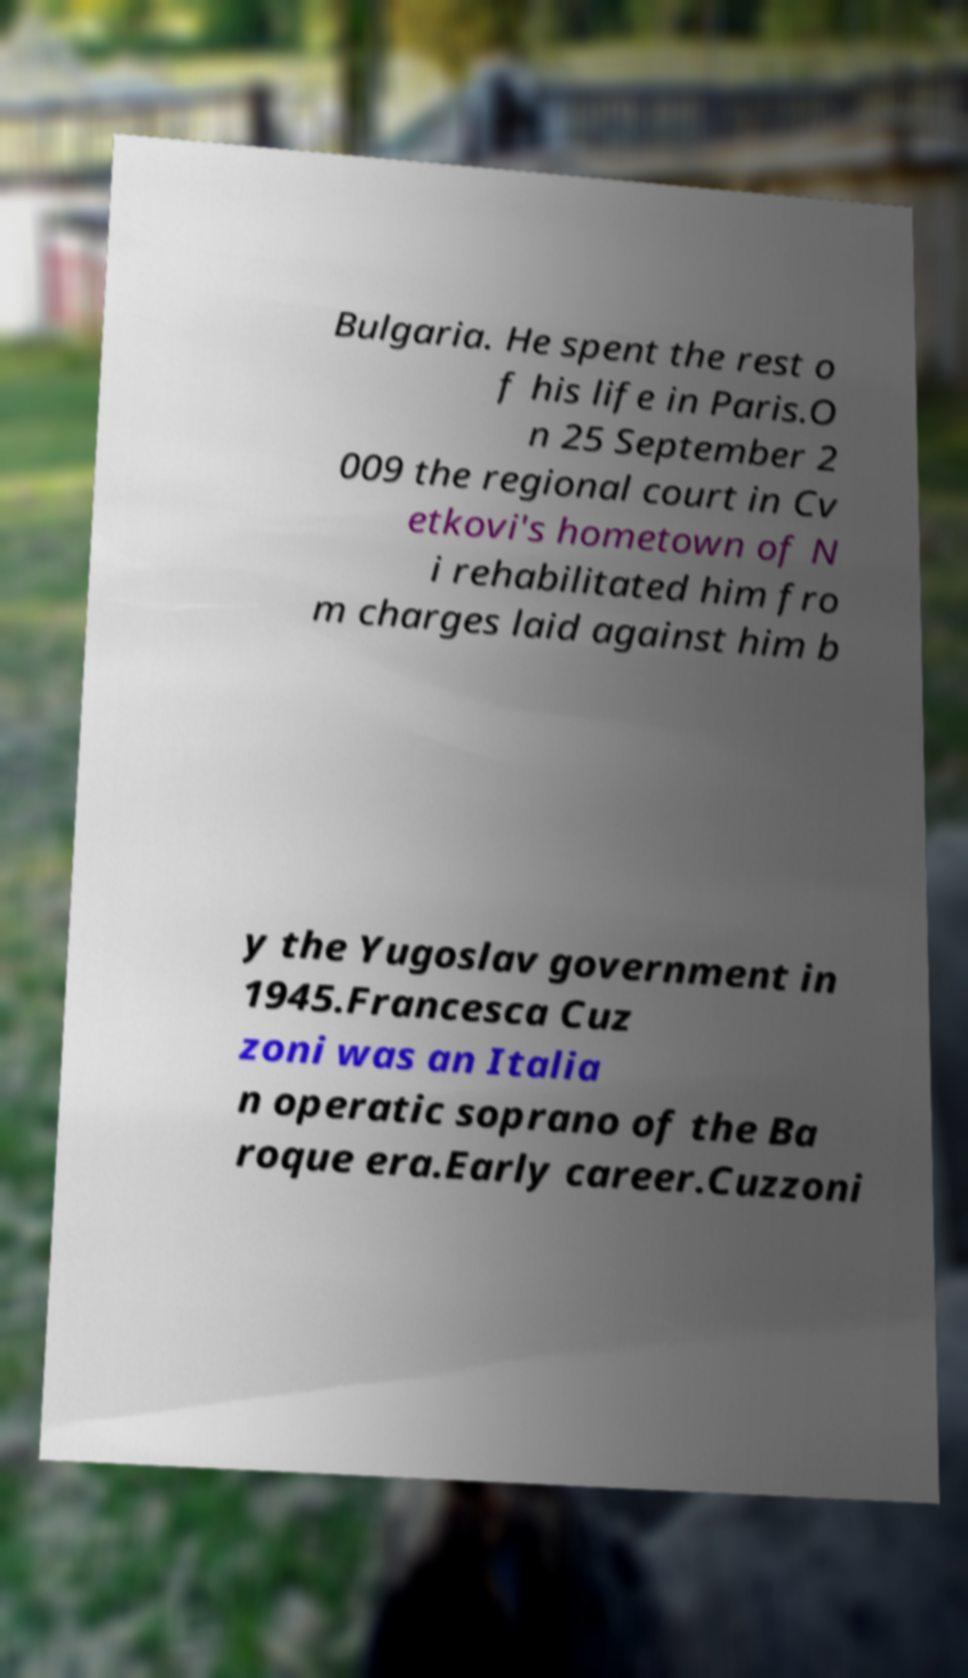Could you assist in decoding the text presented in this image and type it out clearly? Bulgaria. He spent the rest o f his life in Paris.O n 25 September 2 009 the regional court in Cv etkovi's hometown of N i rehabilitated him fro m charges laid against him b y the Yugoslav government in 1945.Francesca Cuz zoni was an Italia n operatic soprano of the Ba roque era.Early career.Cuzzoni 